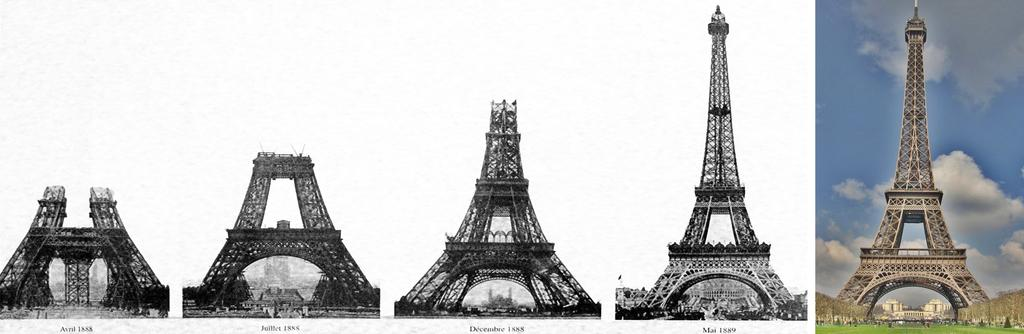What type of insurance policy is being discussed in the image? There is no discussion or any reference to insurance in the image. 